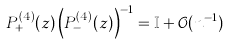Convert formula to latex. <formula><loc_0><loc_0><loc_500><loc_500>P ^ { ( 4 ) } _ { + } ( z ) \left ( P ^ { ( 4 ) } _ { - } ( z ) \right ) ^ { - 1 } = \mathbb { I } + \mathcal { O } ( n ^ { - 1 } )</formula> 